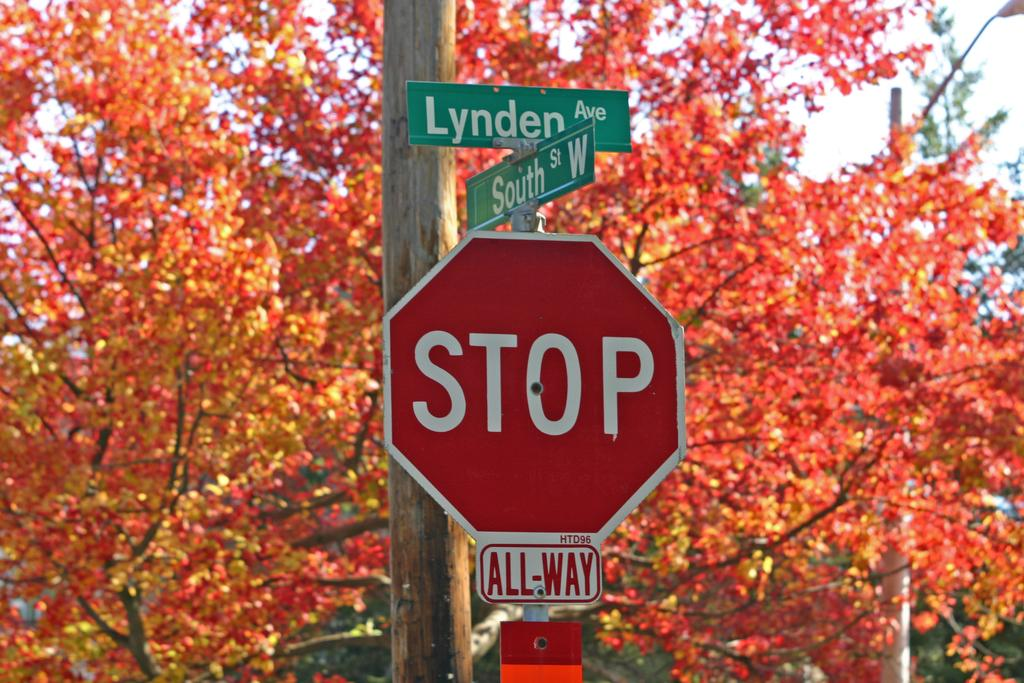Provide a one-sentence caption for the provided image. A stop sign is in front of a bright orange tree. 